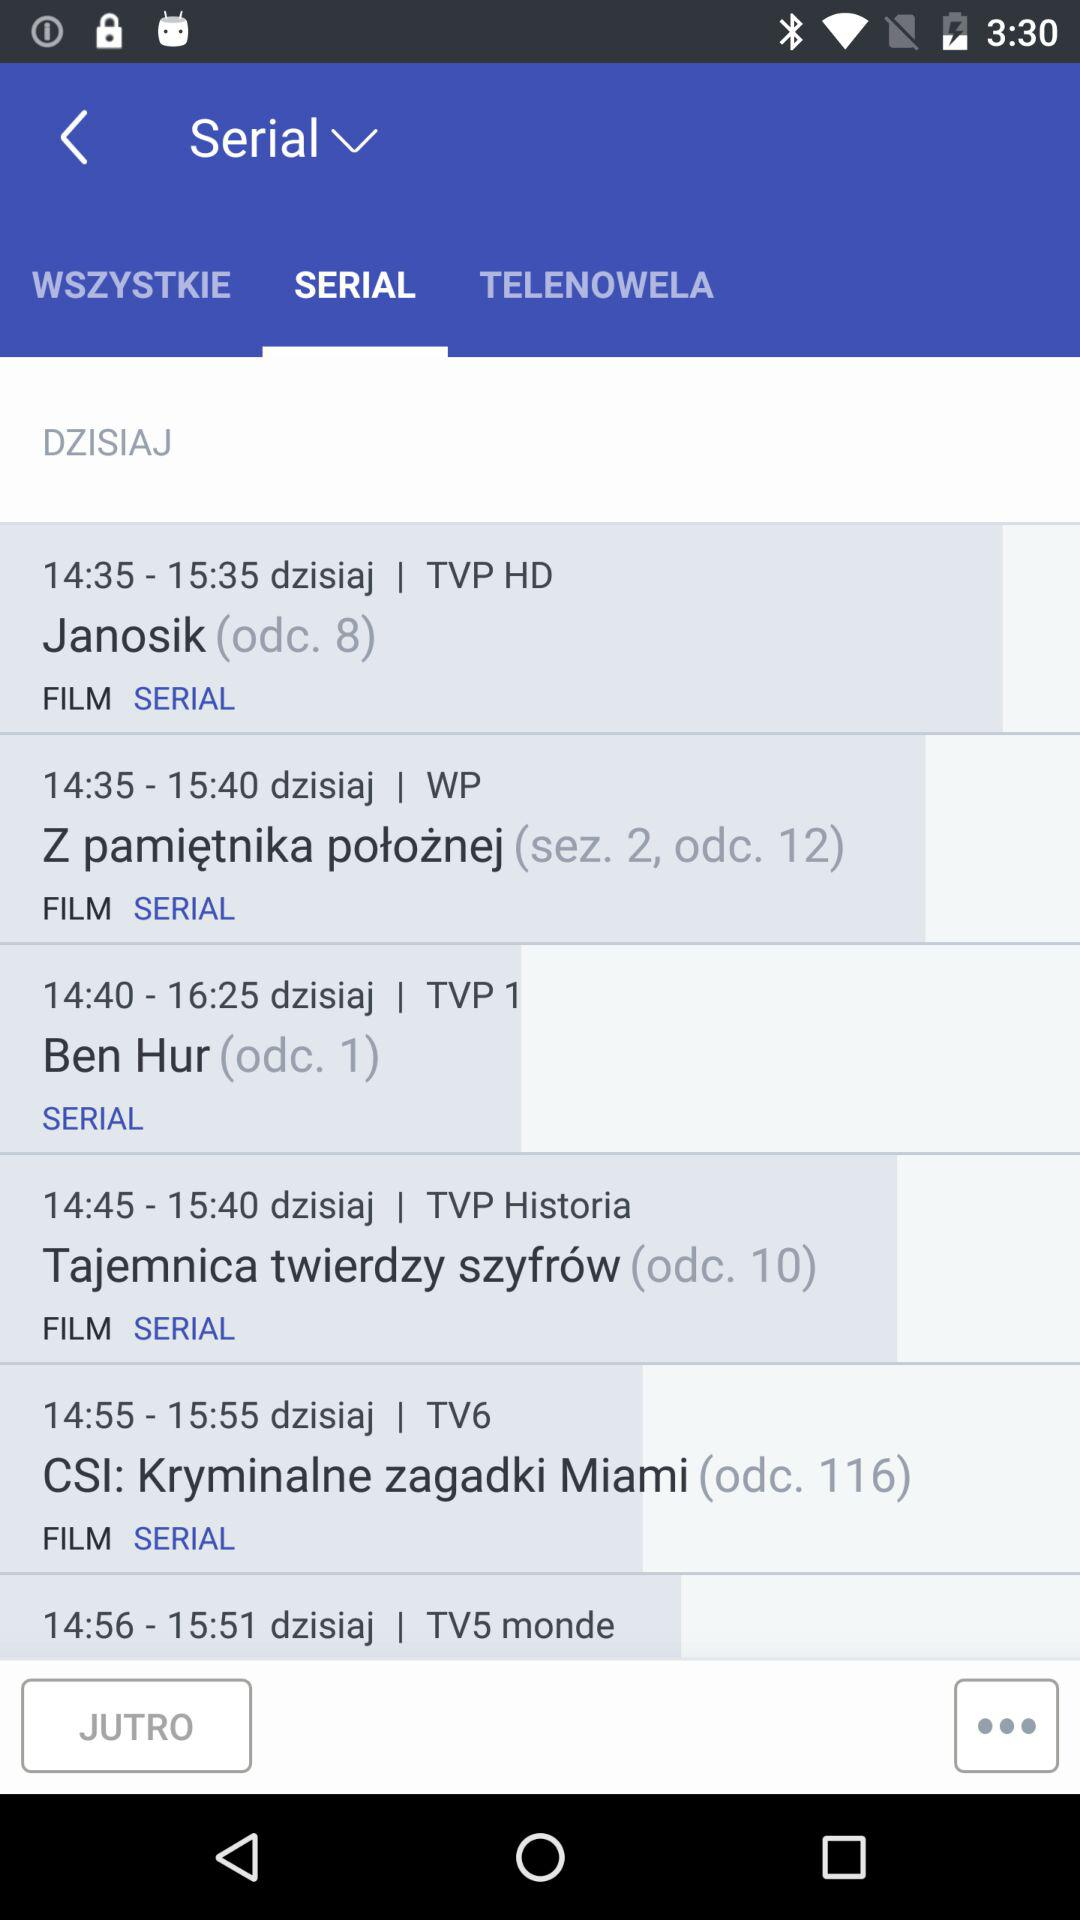Which tab is selected? The selected tab is "SERIAL". 